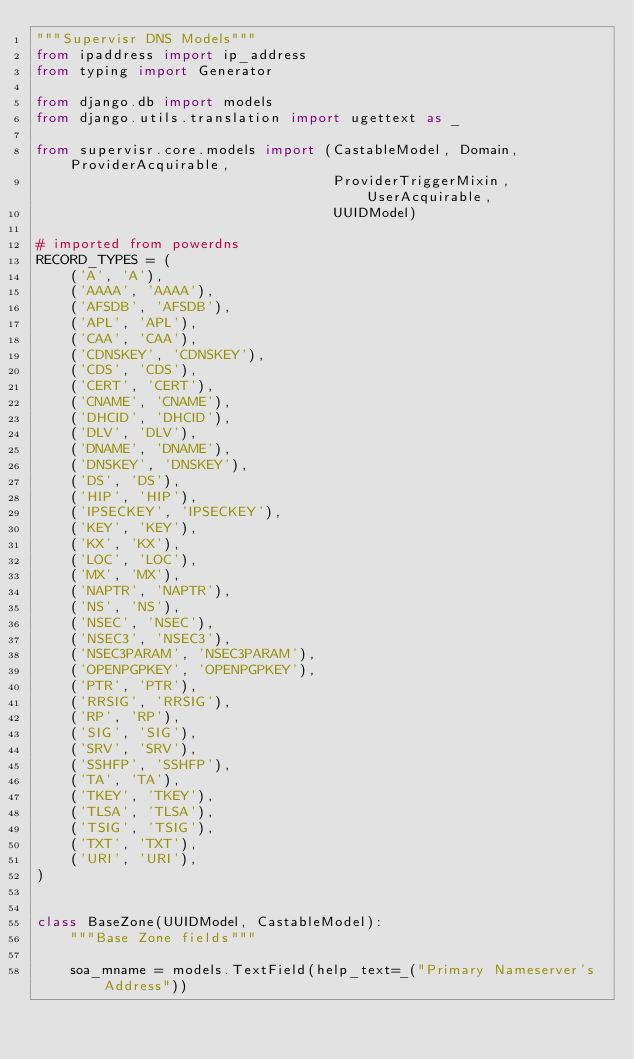Convert code to text. <code><loc_0><loc_0><loc_500><loc_500><_Python_>"""Supervisr DNS Models"""
from ipaddress import ip_address
from typing import Generator

from django.db import models
from django.utils.translation import ugettext as _

from supervisr.core.models import (CastableModel, Domain, ProviderAcquirable,
                                   ProviderTriggerMixin, UserAcquirable,
                                   UUIDModel)

# imported from powerdns
RECORD_TYPES = (
    ('A', 'A'),
    ('AAAA', 'AAAA'),
    ('AFSDB', 'AFSDB'),
    ('APL', 'APL'),
    ('CAA', 'CAA'),
    ('CDNSKEY', 'CDNSKEY'),
    ('CDS', 'CDS'),
    ('CERT', 'CERT'),
    ('CNAME', 'CNAME'),
    ('DHCID', 'DHCID'),
    ('DLV', 'DLV'),
    ('DNAME', 'DNAME'),
    ('DNSKEY', 'DNSKEY'),
    ('DS', 'DS'),
    ('HIP', 'HIP'),
    ('IPSECKEY', 'IPSECKEY'),
    ('KEY', 'KEY'),
    ('KX', 'KX'),
    ('LOC', 'LOC'),
    ('MX', 'MX'),
    ('NAPTR', 'NAPTR'),
    ('NS', 'NS'),
    ('NSEC', 'NSEC'),
    ('NSEC3', 'NSEC3'),
    ('NSEC3PARAM', 'NSEC3PARAM'),
    ('OPENPGPKEY', 'OPENPGPKEY'),
    ('PTR', 'PTR'),
    ('RRSIG', 'RRSIG'),
    ('RP', 'RP'),
    ('SIG', 'SIG'),
    ('SRV', 'SRV'),
    ('SSHFP', 'SSHFP'),
    ('TA', 'TA'),
    ('TKEY', 'TKEY'),
    ('TLSA', 'TLSA'),
    ('TSIG', 'TSIG'),
    ('TXT', 'TXT'),
    ('URI', 'URI'),
)


class BaseZone(UUIDModel, CastableModel):
    """Base Zone fields"""

    soa_mname = models.TextField(help_text=_("Primary Nameserver's Address"))</code> 